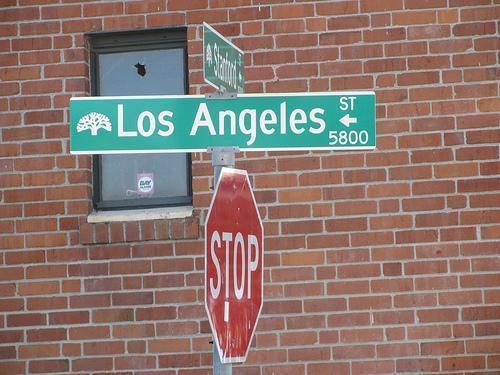How many street signs are up?
Give a very brief answer. 2. 